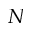Convert formula to latex. <formula><loc_0><loc_0><loc_500><loc_500>N</formula> 